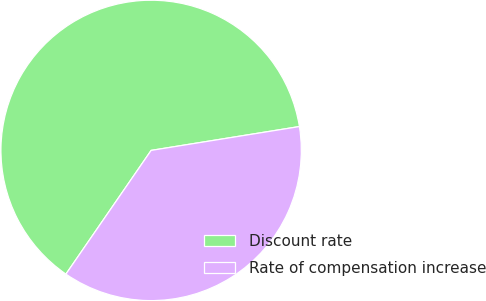Convert chart to OTSL. <chart><loc_0><loc_0><loc_500><loc_500><pie_chart><fcel>Discount rate<fcel>Rate of compensation increase<nl><fcel>62.86%<fcel>37.14%<nl></chart> 